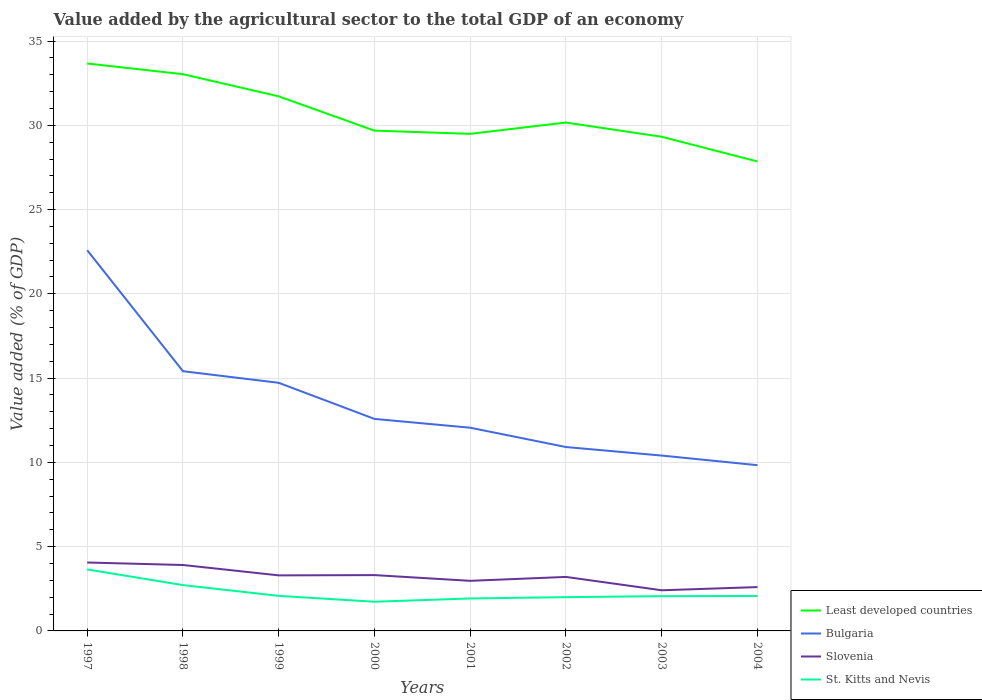How many different coloured lines are there?
Provide a short and direct response. 4. Across all years, what is the maximum value added by the agricultural sector to the total GDP in Bulgaria?
Your answer should be compact. 9.83. What is the total value added by the agricultural sector to the total GDP in Bulgaria in the graph?
Provide a succinct answer. 1.65. What is the difference between the highest and the second highest value added by the agricultural sector to the total GDP in Slovenia?
Offer a terse response. 1.65. What is the difference between the highest and the lowest value added by the agricultural sector to the total GDP in Slovenia?
Your response must be concise. 4. Does the graph contain grids?
Your answer should be very brief. Yes. How many legend labels are there?
Offer a terse response. 4. How are the legend labels stacked?
Your answer should be very brief. Vertical. What is the title of the graph?
Ensure brevity in your answer.  Value added by the agricultural sector to the total GDP of an economy. Does "Japan" appear as one of the legend labels in the graph?
Your answer should be very brief. No. What is the label or title of the X-axis?
Your response must be concise. Years. What is the label or title of the Y-axis?
Offer a terse response. Value added (% of GDP). What is the Value added (% of GDP) in Least developed countries in 1997?
Give a very brief answer. 33.67. What is the Value added (% of GDP) of Bulgaria in 1997?
Provide a succinct answer. 22.59. What is the Value added (% of GDP) of Slovenia in 1997?
Offer a very short reply. 4.06. What is the Value added (% of GDP) of St. Kitts and Nevis in 1997?
Provide a short and direct response. 3.65. What is the Value added (% of GDP) of Least developed countries in 1998?
Give a very brief answer. 33.04. What is the Value added (% of GDP) of Bulgaria in 1998?
Make the answer very short. 15.41. What is the Value added (% of GDP) in Slovenia in 1998?
Keep it short and to the point. 3.91. What is the Value added (% of GDP) in St. Kitts and Nevis in 1998?
Offer a terse response. 2.72. What is the Value added (% of GDP) in Least developed countries in 1999?
Give a very brief answer. 31.72. What is the Value added (% of GDP) in Bulgaria in 1999?
Offer a very short reply. 14.72. What is the Value added (% of GDP) of Slovenia in 1999?
Your answer should be very brief. 3.3. What is the Value added (% of GDP) in St. Kitts and Nevis in 1999?
Ensure brevity in your answer.  2.08. What is the Value added (% of GDP) of Least developed countries in 2000?
Your answer should be very brief. 29.69. What is the Value added (% of GDP) in Bulgaria in 2000?
Your response must be concise. 12.58. What is the Value added (% of GDP) of Slovenia in 2000?
Give a very brief answer. 3.31. What is the Value added (% of GDP) of St. Kitts and Nevis in 2000?
Your answer should be very brief. 1.73. What is the Value added (% of GDP) of Least developed countries in 2001?
Your answer should be compact. 29.49. What is the Value added (% of GDP) of Bulgaria in 2001?
Ensure brevity in your answer.  12.06. What is the Value added (% of GDP) in Slovenia in 2001?
Your answer should be compact. 2.97. What is the Value added (% of GDP) of St. Kitts and Nevis in 2001?
Offer a terse response. 1.93. What is the Value added (% of GDP) of Least developed countries in 2002?
Offer a terse response. 30.17. What is the Value added (% of GDP) of Bulgaria in 2002?
Your answer should be compact. 10.91. What is the Value added (% of GDP) in Slovenia in 2002?
Give a very brief answer. 3.2. What is the Value added (% of GDP) in St. Kitts and Nevis in 2002?
Offer a terse response. 2. What is the Value added (% of GDP) in Least developed countries in 2003?
Your answer should be very brief. 29.32. What is the Value added (% of GDP) in Bulgaria in 2003?
Make the answer very short. 10.4. What is the Value added (% of GDP) in Slovenia in 2003?
Your response must be concise. 2.41. What is the Value added (% of GDP) of St. Kitts and Nevis in 2003?
Ensure brevity in your answer.  2.06. What is the Value added (% of GDP) in Least developed countries in 2004?
Provide a succinct answer. 27.86. What is the Value added (% of GDP) of Bulgaria in 2004?
Provide a succinct answer. 9.83. What is the Value added (% of GDP) of Slovenia in 2004?
Your answer should be compact. 2.6. What is the Value added (% of GDP) in St. Kitts and Nevis in 2004?
Provide a succinct answer. 2.07. Across all years, what is the maximum Value added (% of GDP) of Least developed countries?
Provide a succinct answer. 33.67. Across all years, what is the maximum Value added (% of GDP) of Bulgaria?
Your answer should be very brief. 22.59. Across all years, what is the maximum Value added (% of GDP) of Slovenia?
Offer a terse response. 4.06. Across all years, what is the maximum Value added (% of GDP) in St. Kitts and Nevis?
Make the answer very short. 3.65. Across all years, what is the minimum Value added (% of GDP) in Least developed countries?
Make the answer very short. 27.86. Across all years, what is the minimum Value added (% of GDP) of Bulgaria?
Your answer should be compact. 9.83. Across all years, what is the minimum Value added (% of GDP) in Slovenia?
Provide a succinct answer. 2.41. Across all years, what is the minimum Value added (% of GDP) of St. Kitts and Nevis?
Make the answer very short. 1.73. What is the total Value added (% of GDP) in Least developed countries in the graph?
Offer a terse response. 244.95. What is the total Value added (% of GDP) of Bulgaria in the graph?
Make the answer very short. 108.51. What is the total Value added (% of GDP) of Slovenia in the graph?
Your answer should be compact. 25.77. What is the total Value added (% of GDP) in St. Kitts and Nevis in the graph?
Give a very brief answer. 18.25. What is the difference between the Value added (% of GDP) in Least developed countries in 1997 and that in 1998?
Keep it short and to the point. 0.63. What is the difference between the Value added (% of GDP) of Bulgaria in 1997 and that in 1998?
Give a very brief answer. 7.18. What is the difference between the Value added (% of GDP) in Slovenia in 1997 and that in 1998?
Your answer should be compact. 0.15. What is the difference between the Value added (% of GDP) of St. Kitts and Nevis in 1997 and that in 1998?
Provide a short and direct response. 0.93. What is the difference between the Value added (% of GDP) in Least developed countries in 1997 and that in 1999?
Provide a short and direct response. 1.95. What is the difference between the Value added (% of GDP) of Bulgaria in 1997 and that in 1999?
Give a very brief answer. 7.87. What is the difference between the Value added (% of GDP) of Slovenia in 1997 and that in 1999?
Provide a short and direct response. 0.76. What is the difference between the Value added (% of GDP) in St. Kitts and Nevis in 1997 and that in 1999?
Give a very brief answer. 1.57. What is the difference between the Value added (% of GDP) in Least developed countries in 1997 and that in 2000?
Give a very brief answer. 3.98. What is the difference between the Value added (% of GDP) in Bulgaria in 1997 and that in 2000?
Provide a succinct answer. 10.01. What is the difference between the Value added (% of GDP) in Slovenia in 1997 and that in 2000?
Your response must be concise. 0.75. What is the difference between the Value added (% of GDP) in St. Kitts and Nevis in 1997 and that in 2000?
Your answer should be compact. 1.92. What is the difference between the Value added (% of GDP) of Least developed countries in 1997 and that in 2001?
Offer a very short reply. 4.18. What is the difference between the Value added (% of GDP) of Bulgaria in 1997 and that in 2001?
Ensure brevity in your answer.  10.53. What is the difference between the Value added (% of GDP) of Slovenia in 1997 and that in 2001?
Provide a succinct answer. 1.09. What is the difference between the Value added (% of GDP) of St. Kitts and Nevis in 1997 and that in 2001?
Keep it short and to the point. 1.72. What is the difference between the Value added (% of GDP) of Least developed countries in 1997 and that in 2002?
Provide a succinct answer. 3.5. What is the difference between the Value added (% of GDP) of Bulgaria in 1997 and that in 2002?
Keep it short and to the point. 11.68. What is the difference between the Value added (% of GDP) in Slovenia in 1997 and that in 2002?
Make the answer very short. 0.86. What is the difference between the Value added (% of GDP) of St. Kitts and Nevis in 1997 and that in 2002?
Your response must be concise. 1.65. What is the difference between the Value added (% of GDP) in Least developed countries in 1997 and that in 2003?
Give a very brief answer. 4.35. What is the difference between the Value added (% of GDP) of Bulgaria in 1997 and that in 2003?
Make the answer very short. 12.18. What is the difference between the Value added (% of GDP) of Slovenia in 1997 and that in 2003?
Give a very brief answer. 1.65. What is the difference between the Value added (% of GDP) of St. Kitts and Nevis in 1997 and that in 2003?
Keep it short and to the point. 1.59. What is the difference between the Value added (% of GDP) in Least developed countries in 1997 and that in 2004?
Offer a terse response. 5.81. What is the difference between the Value added (% of GDP) in Bulgaria in 1997 and that in 2004?
Offer a very short reply. 12.75. What is the difference between the Value added (% of GDP) of Slovenia in 1997 and that in 2004?
Offer a very short reply. 1.46. What is the difference between the Value added (% of GDP) of St. Kitts and Nevis in 1997 and that in 2004?
Provide a succinct answer. 1.58. What is the difference between the Value added (% of GDP) in Least developed countries in 1998 and that in 1999?
Your answer should be compact. 1.31. What is the difference between the Value added (% of GDP) in Bulgaria in 1998 and that in 1999?
Provide a succinct answer. 0.69. What is the difference between the Value added (% of GDP) of Slovenia in 1998 and that in 1999?
Your response must be concise. 0.62. What is the difference between the Value added (% of GDP) of St. Kitts and Nevis in 1998 and that in 1999?
Offer a very short reply. 0.64. What is the difference between the Value added (% of GDP) in Least developed countries in 1998 and that in 2000?
Ensure brevity in your answer.  3.35. What is the difference between the Value added (% of GDP) in Bulgaria in 1998 and that in 2000?
Your answer should be very brief. 2.83. What is the difference between the Value added (% of GDP) of Slovenia in 1998 and that in 2000?
Provide a succinct answer. 0.6. What is the difference between the Value added (% of GDP) in St. Kitts and Nevis in 1998 and that in 2000?
Give a very brief answer. 0.99. What is the difference between the Value added (% of GDP) of Least developed countries in 1998 and that in 2001?
Provide a succinct answer. 3.54. What is the difference between the Value added (% of GDP) in Bulgaria in 1998 and that in 2001?
Give a very brief answer. 3.35. What is the difference between the Value added (% of GDP) of Slovenia in 1998 and that in 2001?
Keep it short and to the point. 0.94. What is the difference between the Value added (% of GDP) in St. Kitts and Nevis in 1998 and that in 2001?
Your response must be concise. 0.79. What is the difference between the Value added (% of GDP) in Least developed countries in 1998 and that in 2002?
Provide a succinct answer. 2.87. What is the difference between the Value added (% of GDP) of Bulgaria in 1998 and that in 2002?
Your answer should be compact. 4.5. What is the difference between the Value added (% of GDP) in Slovenia in 1998 and that in 2002?
Provide a short and direct response. 0.71. What is the difference between the Value added (% of GDP) in St. Kitts and Nevis in 1998 and that in 2002?
Your answer should be very brief. 0.72. What is the difference between the Value added (% of GDP) of Least developed countries in 1998 and that in 2003?
Provide a succinct answer. 3.71. What is the difference between the Value added (% of GDP) in Bulgaria in 1998 and that in 2003?
Give a very brief answer. 5.01. What is the difference between the Value added (% of GDP) in Slovenia in 1998 and that in 2003?
Your response must be concise. 1.5. What is the difference between the Value added (% of GDP) in St. Kitts and Nevis in 1998 and that in 2003?
Ensure brevity in your answer.  0.66. What is the difference between the Value added (% of GDP) of Least developed countries in 1998 and that in 2004?
Your answer should be compact. 5.18. What is the difference between the Value added (% of GDP) in Bulgaria in 1998 and that in 2004?
Your answer should be compact. 5.58. What is the difference between the Value added (% of GDP) in Slovenia in 1998 and that in 2004?
Offer a terse response. 1.31. What is the difference between the Value added (% of GDP) in St. Kitts and Nevis in 1998 and that in 2004?
Keep it short and to the point. 0.65. What is the difference between the Value added (% of GDP) in Least developed countries in 1999 and that in 2000?
Keep it short and to the point. 2.03. What is the difference between the Value added (% of GDP) of Bulgaria in 1999 and that in 2000?
Keep it short and to the point. 2.14. What is the difference between the Value added (% of GDP) in Slovenia in 1999 and that in 2000?
Your response must be concise. -0.02. What is the difference between the Value added (% of GDP) in St. Kitts and Nevis in 1999 and that in 2000?
Ensure brevity in your answer.  0.35. What is the difference between the Value added (% of GDP) in Least developed countries in 1999 and that in 2001?
Provide a succinct answer. 2.23. What is the difference between the Value added (% of GDP) in Bulgaria in 1999 and that in 2001?
Provide a succinct answer. 2.66. What is the difference between the Value added (% of GDP) in Slovenia in 1999 and that in 2001?
Your answer should be very brief. 0.32. What is the difference between the Value added (% of GDP) in St. Kitts and Nevis in 1999 and that in 2001?
Ensure brevity in your answer.  0.16. What is the difference between the Value added (% of GDP) in Least developed countries in 1999 and that in 2002?
Your answer should be compact. 1.55. What is the difference between the Value added (% of GDP) in Bulgaria in 1999 and that in 2002?
Keep it short and to the point. 3.81. What is the difference between the Value added (% of GDP) in Slovenia in 1999 and that in 2002?
Offer a terse response. 0.09. What is the difference between the Value added (% of GDP) of St. Kitts and Nevis in 1999 and that in 2002?
Offer a very short reply. 0.08. What is the difference between the Value added (% of GDP) of Least developed countries in 1999 and that in 2003?
Your response must be concise. 2.4. What is the difference between the Value added (% of GDP) in Bulgaria in 1999 and that in 2003?
Your answer should be very brief. 4.32. What is the difference between the Value added (% of GDP) of Slovenia in 1999 and that in 2003?
Ensure brevity in your answer.  0.88. What is the difference between the Value added (% of GDP) of St. Kitts and Nevis in 1999 and that in 2003?
Your answer should be compact. 0.02. What is the difference between the Value added (% of GDP) of Least developed countries in 1999 and that in 2004?
Offer a terse response. 3.86. What is the difference between the Value added (% of GDP) in Bulgaria in 1999 and that in 2004?
Ensure brevity in your answer.  4.89. What is the difference between the Value added (% of GDP) in Slovenia in 1999 and that in 2004?
Offer a terse response. 0.69. What is the difference between the Value added (% of GDP) of St. Kitts and Nevis in 1999 and that in 2004?
Provide a short and direct response. 0.01. What is the difference between the Value added (% of GDP) in Least developed countries in 2000 and that in 2001?
Provide a short and direct response. 0.19. What is the difference between the Value added (% of GDP) in Bulgaria in 2000 and that in 2001?
Ensure brevity in your answer.  0.52. What is the difference between the Value added (% of GDP) in Slovenia in 2000 and that in 2001?
Provide a succinct answer. 0.34. What is the difference between the Value added (% of GDP) of St. Kitts and Nevis in 2000 and that in 2001?
Your answer should be very brief. -0.19. What is the difference between the Value added (% of GDP) of Least developed countries in 2000 and that in 2002?
Ensure brevity in your answer.  -0.48. What is the difference between the Value added (% of GDP) of Bulgaria in 2000 and that in 2002?
Ensure brevity in your answer.  1.67. What is the difference between the Value added (% of GDP) of Slovenia in 2000 and that in 2002?
Your answer should be very brief. 0.11. What is the difference between the Value added (% of GDP) in St. Kitts and Nevis in 2000 and that in 2002?
Provide a succinct answer. -0.27. What is the difference between the Value added (% of GDP) of Least developed countries in 2000 and that in 2003?
Offer a very short reply. 0.37. What is the difference between the Value added (% of GDP) in Bulgaria in 2000 and that in 2003?
Keep it short and to the point. 2.17. What is the difference between the Value added (% of GDP) in Slovenia in 2000 and that in 2003?
Your response must be concise. 0.9. What is the difference between the Value added (% of GDP) in St. Kitts and Nevis in 2000 and that in 2003?
Make the answer very short. -0.33. What is the difference between the Value added (% of GDP) of Least developed countries in 2000 and that in 2004?
Give a very brief answer. 1.83. What is the difference between the Value added (% of GDP) of Bulgaria in 2000 and that in 2004?
Keep it short and to the point. 2.75. What is the difference between the Value added (% of GDP) of Slovenia in 2000 and that in 2004?
Give a very brief answer. 0.71. What is the difference between the Value added (% of GDP) of St. Kitts and Nevis in 2000 and that in 2004?
Your answer should be compact. -0.34. What is the difference between the Value added (% of GDP) of Least developed countries in 2001 and that in 2002?
Your response must be concise. -0.67. What is the difference between the Value added (% of GDP) of Bulgaria in 2001 and that in 2002?
Your response must be concise. 1.15. What is the difference between the Value added (% of GDP) of Slovenia in 2001 and that in 2002?
Ensure brevity in your answer.  -0.23. What is the difference between the Value added (% of GDP) in St. Kitts and Nevis in 2001 and that in 2002?
Provide a succinct answer. -0.08. What is the difference between the Value added (% of GDP) in Least developed countries in 2001 and that in 2003?
Keep it short and to the point. 0.17. What is the difference between the Value added (% of GDP) in Bulgaria in 2001 and that in 2003?
Offer a very short reply. 1.65. What is the difference between the Value added (% of GDP) in Slovenia in 2001 and that in 2003?
Your response must be concise. 0.56. What is the difference between the Value added (% of GDP) in St. Kitts and Nevis in 2001 and that in 2003?
Make the answer very short. -0.14. What is the difference between the Value added (% of GDP) in Least developed countries in 2001 and that in 2004?
Give a very brief answer. 1.64. What is the difference between the Value added (% of GDP) in Bulgaria in 2001 and that in 2004?
Offer a very short reply. 2.22. What is the difference between the Value added (% of GDP) in Slovenia in 2001 and that in 2004?
Ensure brevity in your answer.  0.37. What is the difference between the Value added (% of GDP) of St. Kitts and Nevis in 2001 and that in 2004?
Ensure brevity in your answer.  -0.15. What is the difference between the Value added (% of GDP) in Least developed countries in 2002 and that in 2003?
Provide a succinct answer. 0.85. What is the difference between the Value added (% of GDP) of Bulgaria in 2002 and that in 2003?
Keep it short and to the point. 0.51. What is the difference between the Value added (% of GDP) of Slovenia in 2002 and that in 2003?
Ensure brevity in your answer.  0.79. What is the difference between the Value added (% of GDP) of St. Kitts and Nevis in 2002 and that in 2003?
Offer a terse response. -0.06. What is the difference between the Value added (% of GDP) of Least developed countries in 2002 and that in 2004?
Provide a short and direct response. 2.31. What is the difference between the Value added (% of GDP) in Bulgaria in 2002 and that in 2004?
Give a very brief answer. 1.08. What is the difference between the Value added (% of GDP) in Slovenia in 2002 and that in 2004?
Provide a succinct answer. 0.6. What is the difference between the Value added (% of GDP) in St. Kitts and Nevis in 2002 and that in 2004?
Your answer should be very brief. -0.07. What is the difference between the Value added (% of GDP) of Least developed countries in 2003 and that in 2004?
Keep it short and to the point. 1.46. What is the difference between the Value added (% of GDP) in Bulgaria in 2003 and that in 2004?
Provide a short and direct response. 0.57. What is the difference between the Value added (% of GDP) in Slovenia in 2003 and that in 2004?
Your answer should be compact. -0.19. What is the difference between the Value added (% of GDP) of St. Kitts and Nevis in 2003 and that in 2004?
Provide a succinct answer. -0.01. What is the difference between the Value added (% of GDP) of Least developed countries in 1997 and the Value added (% of GDP) of Bulgaria in 1998?
Make the answer very short. 18.26. What is the difference between the Value added (% of GDP) in Least developed countries in 1997 and the Value added (% of GDP) in Slovenia in 1998?
Offer a very short reply. 29.76. What is the difference between the Value added (% of GDP) of Least developed countries in 1997 and the Value added (% of GDP) of St. Kitts and Nevis in 1998?
Offer a terse response. 30.95. What is the difference between the Value added (% of GDP) of Bulgaria in 1997 and the Value added (% of GDP) of Slovenia in 1998?
Make the answer very short. 18.68. What is the difference between the Value added (% of GDP) in Bulgaria in 1997 and the Value added (% of GDP) in St. Kitts and Nevis in 1998?
Make the answer very short. 19.87. What is the difference between the Value added (% of GDP) in Slovenia in 1997 and the Value added (% of GDP) in St. Kitts and Nevis in 1998?
Your answer should be very brief. 1.34. What is the difference between the Value added (% of GDP) in Least developed countries in 1997 and the Value added (% of GDP) in Bulgaria in 1999?
Provide a succinct answer. 18.95. What is the difference between the Value added (% of GDP) in Least developed countries in 1997 and the Value added (% of GDP) in Slovenia in 1999?
Offer a terse response. 30.37. What is the difference between the Value added (% of GDP) of Least developed countries in 1997 and the Value added (% of GDP) of St. Kitts and Nevis in 1999?
Make the answer very short. 31.59. What is the difference between the Value added (% of GDP) of Bulgaria in 1997 and the Value added (% of GDP) of Slovenia in 1999?
Your response must be concise. 19.29. What is the difference between the Value added (% of GDP) in Bulgaria in 1997 and the Value added (% of GDP) in St. Kitts and Nevis in 1999?
Provide a succinct answer. 20.51. What is the difference between the Value added (% of GDP) in Slovenia in 1997 and the Value added (% of GDP) in St. Kitts and Nevis in 1999?
Provide a succinct answer. 1.98. What is the difference between the Value added (% of GDP) in Least developed countries in 1997 and the Value added (% of GDP) in Bulgaria in 2000?
Provide a succinct answer. 21.09. What is the difference between the Value added (% of GDP) in Least developed countries in 1997 and the Value added (% of GDP) in Slovenia in 2000?
Keep it short and to the point. 30.36. What is the difference between the Value added (% of GDP) in Least developed countries in 1997 and the Value added (% of GDP) in St. Kitts and Nevis in 2000?
Offer a terse response. 31.94. What is the difference between the Value added (% of GDP) of Bulgaria in 1997 and the Value added (% of GDP) of Slovenia in 2000?
Give a very brief answer. 19.28. What is the difference between the Value added (% of GDP) in Bulgaria in 1997 and the Value added (% of GDP) in St. Kitts and Nevis in 2000?
Provide a short and direct response. 20.86. What is the difference between the Value added (% of GDP) in Slovenia in 1997 and the Value added (% of GDP) in St. Kitts and Nevis in 2000?
Your answer should be very brief. 2.33. What is the difference between the Value added (% of GDP) in Least developed countries in 1997 and the Value added (% of GDP) in Bulgaria in 2001?
Your answer should be compact. 21.61. What is the difference between the Value added (% of GDP) in Least developed countries in 1997 and the Value added (% of GDP) in Slovenia in 2001?
Give a very brief answer. 30.7. What is the difference between the Value added (% of GDP) of Least developed countries in 1997 and the Value added (% of GDP) of St. Kitts and Nevis in 2001?
Your response must be concise. 31.74. What is the difference between the Value added (% of GDP) of Bulgaria in 1997 and the Value added (% of GDP) of Slovenia in 2001?
Ensure brevity in your answer.  19.62. What is the difference between the Value added (% of GDP) of Bulgaria in 1997 and the Value added (% of GDP) of St. Kitts and Nevis in 2001?
Give a very brief answer. 20.66. What is the difference between the Value added (% of GDP) in Slovenia in 1997 and the Value added (% of GDP) in St. Kitts and Nevis in 2001?
Ensure brevity in your answer.  2.13. What is the difference between the Value added (% of GDP) in Least developed countries in 1997 and the Value added (% of GDP) in Bulgaria in 2002?
Make the answer very short. 22.76. What is the difference between the Value added (% of GDP) in Least developed countries in 1997 and the Value added (% of GDP) in Slovenia in 2002?
Keep it short and to the point. 30.46. What is the difference between the Value added (% of GDP) of Least developed countries in 1997 and the Value added (% of GDP) of St. Kitts and Nevis in 2002?
Your response must be concise. 31.67. What is the difference between the Value added (% of GDP) of Bulgaria in 1997 and the Value added (% of GDP) of Slovenia in 2002?
Offer a very short reply. 19.39. What is the difference between the Value added (% of GDP) of Bulgaria in 1997 and the Value added (% of GDP) of St. Kitts and Nevis in 2002?
Make the answer very short. 20.59. What is the difference between the Value added (% of GDP) in Slovenia in 1997 and the Value added (% of GDP) in St. Kitts and Nevis in 2002?
Keep it short and to the point. 2.06. What is the difference between the Value added (% of GDP) of Least developed countries in 1997 and the Value added (% of GDP) of Bulgaria in 2003?
Your answer should be very brief. 23.26. What is the difference between the Value added (% of GDP) in Least developed countries in 1997 and the Value added (% of GDP) in Slovenia in 2003?
Make the answer very short. 31.26. What is the difference between the Value added (% of GDP) of Least developed countries in 1997 and the Value added (% of GDP) of St. Kitts and Nevis in 2003?
Offer a very short reply. 31.61. What is the difference between the Value added (% of GDP) in Bulgaria in 1997 and the Value added (% of GDP) in Slovenia in 2003?
Offer a terse response. 20.18. What is the difference between the Value added (% of GDP) in Bulgaria in 1997 and the Value added (% of GDP) in St. Kitts and Nevis in 2003?
Keep it short and to the point. 20.53. What is the difference between the Value added (% of GDP) in Slovenia in 1997 and the Value added (% of GDP) in St. Kitts and Nevis in 2003?
Your response must be concise. 2. What is the difference between the Value added (% of GDP) in Least developed countries in 1997 and the Value added (% of GDP) in Bulgaria in 2004?
Keep it short and to the point. 23.83. What is the difference between the Value added (% of GDP) of Least developed countries in 1997 and the Value added (% of GDP) of Slovenia in 2004?
Make the answer very short. 31.07. What is the difference between the Value added (% of GDP) in Least developed countries in 1997 and the Value added (% of GDP) in St. Kitts and Nevis in 2004?
Provide a short and direct response. 31.6. What is the difference between the Value added (% of GDP) in Bulgaria in 1997 and the Value added (% of GDP) in Slovenia in 2004?
Your response must be concise. 19.99. What is the difference between the Value added (% of GDP) in Bulgaria in 1997 and the Value added (% of GDP) in St. Kitts and Nevis in 2004?
Offer a very short reply. 20.52. What is the difference between the Value added (% of GDP) of Slovenia in 1997 and the Value added (% of GDP) of St. Kitts and Nevis in 2004?
Make the answer very short. 1.99. What is the difference between the Value added (% of GDP) of Least developed countries in 1998 and the Value added (% of GDP) of Bulgaria in 1999?
Give a very brief answer. 18.31. What is the difference between the Value added (% of GDP) of Least developed countries in 1998 and the Value added (% of GDP) of Slovenia in 1999?
Your answer should be very brief. 29.74. What is the difference between the Value added (% of GDP) of Least developed countries in 1998 and the Value added (% of GDP) of St. Kitts and Nevis in 1999?
Provide a short and direct response. 30.95. What is the difference between the Value added (% of GDP) of Bulgaria in 1998 and the Value added (% of GDP) of Slovenia in 1999?
Keep it short and to the point. 12.12. What is the difference between the Value added (% of GDP) of Bulgaria in 1998 and the Value added (% of GDP) of St. Kitts and Nevis in 1999?
Keep it short and to the point. 13.33. What is the difference between the Value added (% of GDP) in Slovenia in 1998 and the Value added (% of GDP) in St. Kitts and Nevis in 1999?
Your answer should be compact. 1.83. What is the difference between the Value added (% of GDP) of Least developed countries in 1998 and the Value added (% of GDP) of Bulgaria in 2000?
Your response must be concise. 20.46. What is the difference between the Value added (% of GDP) of Least developed countries in 1998 and the Value added (% of GDP) of Slovenia in 2000?
Offer a terse response. 29.72. What is the difference between the Value added (% of GDP) in Least developed countries in 1998 and the Value added (% of GDP) in St. Kitts and Nevis in 2000?
Offer a very short reply. 31.3. What is the difference between the Value added (% of GDP) in Bulgaria in 1998 and the Value added (% of GDP) in Slovenia in 2000?
Your answer should be compact. 12.1. What is the difference between the Value added (% of GDP) in Bulgaria in 1998 and the Value added (% of GDP) in St. Kitts and Nevis in 2000?
Keep it short and to the point. 13.68. What is the difference between the Value added (% of GDP) of Slovenia in 1998 and the Value added (% of GDP) of St. Kitts and Nevis in 2000?
Your answer should be very brief. 2.18. What is the difference between the Value added (% of GDP) of Least developed countries in 1998 and the Value added (% of GDP) of Bulgaria in 2001?
Provide a succinct answer. 20.98. What is the difference between the Value added (% of GDP) in Least developed countries in 1998 and the Value added (% of GDP) in Slovenia in 2001?
Offer a terse response. 30.06. What is the difference between the Value added (% of GDP) of Least developed countries in 1998 and the Value added (% of GDP) of St. Kitts and Nevis in 2001?
Make the answer very short. 31.11. What is the difference between the Value added (% of GDP) of Bulgaria in 1998 and the Value added (% of GDP) of Slovenia in 2001?
Provide a succinct answer. 12.44. What is the difference between the Value added (% of GDP) of Bulgaria in 1998 and the Value added (% of GDP) of St. Kitts and Nevis in 2001?
Your answer should be compact. 13.49. What is the difference between the Value added (% of GDP) of Slovenia in 1998 and the Value added (% of GDP) of St. Kitts and Nevis in 2001?
Provide a succinct answer. 1.99. What is the difference between the Value added (% of GDP) of Least developed countries in 1998 and the Value added (% of GDP) of Bulgaria in 2002?
Give a very brief answer. 22.12. What is the difference between the Value added (% of GDP) in Least developed countries in 1998 and the Value added (% of GDP) in Slovenia in 2002?
Provide a succinct answer. 29.83. What is the difference between the Value added (% of GDP) of Least developed countries in 1998 and the Value added (% of GDP) of St. Kitts and Nevis in 2002?
Give a very brief answer. 31.03. What is the difference between the Value added (% of GDP) of Bulgaria in 1998 and the Value added (% of GDP) of Slovenia in 2002?
Your answer should be very brief. 12.21. What is the difference between the Value added (% of GDP) of Bulgaria in 1998 and the Value added (% of GDP) of St. Kitts and Nevis in 2002?
Provide a short and direct response. 13.41. What is the difference between the Value added (% of GDP) of Slovenia in 1998 and the Value added (% of GDP) of St. Kitts and Nevis in 2002?
Your response must be concise. 1.91. What is the difference between the Value added (% of GDP) of Least developed countries in 1998 and the Value added (% of GDP) of Bulgaria in 2003?
Your answer should be compact. 22.63. What is the difference between the Value added (% of GDP) of Least developed countries in 1998 and the Value added (% of GDP) of Slovenia in 2003?
Make the answer very short. 30.62. What is the difference between the Value added (% of GDP) of Least developed countries in 1998 and the Value added (% of GDP) of St. Kitts and Nevis in 2003?
Give a very brief answer. 30.97. What is the difference between the Value added (% of GDP) in Bulgaria in 1998 and the Value added (% of GDP) in Slovenia in 2003?
Your answer should be compact. 13. What is the difference between the Value added (% of GDP) of Bulgaria in 1998 and the Value added (% of GDP) of St. Kitts and Nevis in 2003?
Make the answer very short. 13.35. What is the difference between the Value added (% of GDP) of Slovenia in 1998 and the Value added (% of GDP) of St. Kitts and Nevis in 2003?
Give a very brief answer. 1.85. What is the difference between the Value added (% of GDP) of Least developed countries in 1998 and the Value added (% of GDP) of Bulgaria in 2004?
Provide a short and direct response. 23.2. What is the difference between the Value added (% of GDP) of Least developed countries in 1998 and the Value added (% of GDP) of Slovenia in 2004?
Offer a very short reply. 30.43. What is the difference between the Value added (% of GDP) of Least developed countries in 1998 and the Value added (% of GDP) of St. Kitts and Nevis in 2004?
Your answer should be compact. 30.96. What is the difference between the Value added (% of GDP) in Bulgaria in 1998 and the Value added (% of GDP) in Slovenia in 2004?
Keep it short and to the point. 12.81. What is the difference between the Value added (% of GDP) in Bulgaria in 1998 and the Value added (% of GDP) in St. Kitts and Nevis in 2004?
Give a very brief answer. 13.34. What is the difference between the Value added (% of GDP) of Slovenia in 1998 and the Value added (% of GDP) of St. Kitts and Nevis in 2004?
Make the answer very short. 1.84. What is the difference between the Value added (% of GDP) in Least developed countries in 1999 and the Value added (% of GDP) in Bulgaria in 2000?
Provide a succinct answer. 19.14. What is the difference between the Value added (% of GDP) of Least developed countries in 1999 and the Value added (% of GDP) of Slovenia in 2000?
Provide a succinct answer. 28.41. What is the difference between the Value added (% of GDP) in Least developed countries in 1999 and the Value added (% of GDP) in St. Kitts and Nevis in 2000?
Ensure brevity in your answer.  29.99. What is the difference between the Value added (% of GDP) in Bulgaria in 1999 and the Value added (% of GDP) in Slovenia in 2000?
Your answer should be compact. 11.41. What is the difference between the Value added (% of GDP) of Bulgaria in 1999 and the Value added (% of GDP) of St. Kitts and Nevis in 2000?
Provide a succinct answer. 12.99. What is the difference between the Value added (% of GDP) of Slovenia in 1999 and the Value added (% of GDP) of St. Kitts and Nevis in 2000?
Your answer should be very brief. 1.56. What is the difference between the Value added (% of GDP) in Least developed countries in 1999 and the Value added (% of GDP) in Bulgaria in 2001?
Your response must be concise. 19.66. What is the difference between the Value added (% of GDP) in Least developed countries in 1999 and the Value added (% of GDP) in Slovenia in 2001?
Offer a terse response. 28.75. What is the difference between the Value added (% of GDP) of Least developed countries in 1999 and the Value added (% of GDP) of St. Kitts and Nevis in 2001?
Give a very brief answer. 29.8. What is the difference between the Value added (% of GDP) in Bulgaria in 1999 and the Value added (% of GDP) in Slovenia in 2001?
Offer a terse response. 11.75. What is the difference between the Value added (% of GDP) of Bulgaria in 1999 and the Value added (% of GDP) of St. Kitts and Nevis in 2001?
Offer a very short reply. 12.8. What is the difference between the Value added (% of GDP) of Slovenia in 1999 and the Value added (% of GDP) of St. Kitts and Nevis in 2001?
Make the answer very short. 1.37. What is the difference between the Value added (% of GDP) in Least developed countries in 1999 and the Value added (% of GDP) in Bulgaria in 2002?
Keep it short and to the point. 20.81. What is the difference between the Value added (% of GDP) in Least developed countries in 1999 and the Value added (% of GDP) in Slovenia in 2002?
Offer a terse response. 28.52. What is the difference between the Value added (% of GDP) of Least developed countries in 1999 and the Value added (% of GDP) of St. Kitts and Nevis in 2002?
Ensure brevity in your answer.  29.72. What is the difference between the Value added (% of GDP) of Bulgaria in 1999 and the Value added (% of GDP) of Slovenia in 2002?
Give a very brief answer. 11.52. What is the difference between the Value added (% of GDP) of Bulgaria in 1999 and the Value added (% of GDP) of St. Kitts and Nevis in 2002?
Your answer should be compact. 12.72. What is the difference between the Value added (% of GDP) of Slovenia in 1999 and the Value added (% of GDP) of St. Kitts and Nevis in 2002?
Make the answer very short. 1.29. What is the difference between the Value added (% of GDP) in Least developed countries in 1999 and the Value added (% of GDP) in Bulgaria in 2003?
Offer a terse response. 21.32. What is the difference between the Value added (% of GDP) in Least developed countries in 1999 and the Value added (% of GDP) in Slovenia in 2003?
Your answer should be compact. 29.31. What is the difference between the Value added (% of GDP) of Least developed countries in 1999 and the Value added (% of GDP) of St. Kitts and Nevis in 2003?
Offer a very short reply. 29.66. What is the difference between the Value added (% of GDP) in Bulgaria in 1999 and the Value added (% of GDP) in Slovenia in 2003?
Your answer should be very brief. 12.31. What is the difference between the Value added (% of GDP) in Bulgaria in 1999 and the Value added (% of GDP) in St. Kitts and Nevis in 2003?
Your response must be concise. 12.66. What is the difference between the Value added (% of GDP) of Slovenia in 1999 and the Value added (% of GDP) of St. Kitts and Nevis in 2003?
Give a very brief answer. 1.23. What is the difference between the Value added (% of GDP) in Least developed countries in 1999 and the Value added (% of GDP) in Bulgaria in 2004?
Offer a terse response. 21.89. What is the difference between the Value added (% of GDP) of Least developed countries in 1999 and the Value added (% of GDP) of Slovenia in 2004?
Your answer should be compact. 29.12. What is the difference between the Value added (% of GDP) of Least developed countries in 1999 and the Value added (% of GDP) of St. Kitts and Nevis in 2004?
Provide a succinct answer. 29.65. What is the difference between the Value added (% of GDP) of Bulgaria in 1999 and the Value added (% of GDP) of Slovenia in 2004?
Your response must be concise. 12.12. What is the difference between the Value added (% of GDP) of Bulgaria in 1999 and the Value added (% of GDP) of St. Kitts and Nevis in 2004?
Your response must be concise. 12.65. What is the difference between the Value added (% of GDP) in Slovenia in 1999 and the Value added (% of GDP) in St. Kitts and Nevis in 2004?
Your answer should be compact. 1.22. What is the difference between the Value added (% of GDP) of Least developed countries in 2000 and the Value added (% of GDP) of Bulgaria in 2001?
Keep it short and to the point. 17.63. What is the difference between the Value added (% of GDP) of Least developed countries in 2000 and the Value added (% of GDP) of Slovenia in 2001?
Your answer should be compact. 26.71. What is the difference between the Value added (% of GDP) of Least developed countries in 2000 and the Value added (% of GDP) of St. Kitts and Nevis in 2001?
Keep it short and to the point. 27.76. What is the difference between the Value added (% of GDP) of Bulgaria in 2000 and the Value added (% of GDP) of Slovenia in 2001?
Your answer should be compact. 9.61. What is the difference between the Value added (% of GDP) in Bulgaria in 2000 and the Value added (% of GDP) in St. Kitts and Nevis in 2001?
Ensure brevity in your answer.  10.65. What is the difference between the Value added (% of GDP) in Slovenia in 2000 and the Value added (% of GDP) in St. Kitts and Nevis in 2001?
Offer a terse response. 1.39. What is the difference between the Value added (% of GDP) in Least developed countries in 2000 and the Value added (% of GDP) in Bulgaria in 2002?
Your response must be concise. 18.78. What is the difference between the Value added (% of GDP) in Least developed countries in 2000 and the Value added (% of GDP) in Slovenia in 2002?
Keep it short and to the point. 26.48. What is the difference between the Value added (% of GDP) of Least developed countries in 2000 and the Value added (% of GDP) of St. Kitts and Nevis in 2002?
Ensure brevity in your answer.  27.68. What is the difference between the Value added (% of GDP) in Bulgaria in 2000 and the Value added (% of GDP) in Slovenia in 2002?
Make the answer very short. 9.38. What is the difference between the Value added (% of GDP) of Bulgaria in 2000 and the Value added (% of GDP) of St. Kitts and Nevis in 2002?
Ensure brevity in your answer.  10.58. What is the difference between the Value added (% of GDP) of Slovenia in 2000 and the Value added (% of GDP) of St. Kitts and Nevis in 2002?
Your response must be concise. 1.31. What is the difference between the Value added (% of GDP) in Least developed countries in 2000 and the Value added (% of GDP) in Bulgaria in 2003?
Your answer should be compact. 19.28. What is the difference between the Value added (% of GDP) of Least developed countries in 2000 and the Value added (% of GDP) of Slovenia in 2003?
Offer a very short reply. 27.27. What is the difference between the Value added (% of GDP) in Least developed countries in 2000 and the Value added (% of GDP) in St. Kitts and Nevis in 2003?
Ensure brevity in your answer.  27.62. What is the difference between the Value added (% of GDP) of Bulgaria in 2000 and the Value added (% of GDP) of Slovenia in 2003?
Give a very brief answer. 10.17. What is the difference between the Value added (% of GDP) of Bulgaria in 2000 and the Value added (% of GDP) of St. Kitts and Nevis in 2003?
Your answer should be very brief. 10.52. What is the difference between the Value added (% of GDP) in Slovenia in 2000 and the Value added (% of GDP) in St. Kitts and Nevis in 2003?
Provide a short and direct response. 1.25. What is the difference between the Value added (% of GDP) of Least developed countries in 2000 and the Value added (% of GDP) of Bulgaria in 2004?
Provide a succinct answer. 19.85. What is the difference between the Value added (% of GDP) in Least developed countries in 2000 and the Value added (% of GDP) in Slovenia in 2004?
Your answer should be compact. 27.09. What is the difference between the Value added (% of GDP) in Least developed countries in 2000 and the Value added (% of GDP) in St. Kitts and Nevis in 2004?
Offer a terse response. 27.61. What is the difference between the Value added (% of GDP) of Bulgaria in 2000 and the Value added (% of GDP) of Slovenia in 2004?
Your response must be concise. 9.98. What is the difference between the Value added (% of GDP) in Bulgaria in 2000 and the Value added (% of GDP) in St. Kitts and Nevis in 2004?
Provide a succinct answer. 10.51. What is the difference between the Value added (% of GDP) in Slovenia in 2000 and the Value added (% of GDP) in St. Kitts and Nevis in 2004?
Ensure brevity in your answer.  1.24. What is the difference between the Value added (% of GDP) in Least developed countries in 2001 and the Value added (% of GDP) in Bulgaria in 2002?
Give a very brief answer. 18.58. What is the difference between the Value added (% of GDP) in Least developed countries in 2001 and the Value added (% of GDP) in Slovenia in 2002?
Offer a terse response. 26.29. What is the difference between the Value added (% of GDP) of Least developed countries in 2001 and the Value added (% of GDP) of St. Kitts and Nevis in 2002?
Your answer should be very brief. 27.49. What is the difference between the Value added (% of GDP) of Bulgaria in 2001 and the Value added (% of GDP) of Slovenia in 2002?
Ensure brevity in your answer.  8.85. What is the difference between the Value added (% of GDP) of Bulgaria in 2001 and the Value added (% of GDP) of St. Kitts and Nevis in 2002?
Give a very brief answer. 10.05. What is the difference between the Value added (% of GDP) in Slovenia in 2001 and the Value added (% of GDP) in St. Kitts and Nevis in 2002?
Keep it short and to the point. 0.97. What is the difference between the Value added (% of GDP) of Least developed countries in 2001 and the Value added (% of GDP) of Bulgaria in 2003?
Offer a terse response. 19.09. What is the difference between the Value added (% of GDP) in Least developed countries in 2001 and the Value added (% of GDP) in Slovenia in 2003?
Give a very brief answer. 27.08. What is the difference between the Value added (% of GDP) of Least developed countries in 2001 and the Value added (% of GDP) of St. Kitts and Nevis in 2003?
Your response must be concise. 27.43. What is the difference between the Value added (% of GDP) in Bulgaria in 2001 and the Value added (% of GDP) in Slovenia in 2003?
Your answer should be compact. 9.65. What is the difference between the Value added (% of GDP) of Bulgaria in 2001 and the Value added (% of GDP) of St. Kitts and Nevis in 2003?
Your answer should be compact. 9.99. What is the difference between the Value added (% of GDP) in Slovenia in 2001 and the Value added (% of GDP) in St. Kitts and Nevis in 2003?
Ensure brevity in your answer.  0.91. What is the difference between the Value added (% of GDP) of Least developed countries in 2001 and the Value added (% of GDP) of Bulgaria in 2004?
Make the answer very short. 19.66. What is the difference between the Value added (% of GDP) in Least developed countries in 2001 and the Value added (% of GDP) in Slovenia in 2004?
Provide a short and direct response. 26.89. What is the difference between the Value added (% of GDP) of Least developed countries in 2001 and the Value added (% of GDP) of St. Kitts and Nevis in 2004?
Give a very brief answer. 27.42. What is the difference between the Value added (% of GDP) in Bulgaria in 2001 and the Value added (% of GDP) in Slovenia in 2004?
Offer a very short reply. 9.46. What is the difference between the Value added (% of GDP) of Bulgaria in 2001 and the Value added (% of GDP) of St. Kitts and Nevis in 2004?
Make the answer very short. 9.98. What is the difference between the Value added (% of GDP) in Slovenia in 2001 and the Value added (% of GDP) in St. Kitts and Nevis in 2004?
Offer a very short reply. 0.9. What is the difference between the Value added (% of GDP) of Least developed countries in 2002 and the Value added (% of GDP) of Bulgaria in 2003?
Your response must be concise. 19.76. What is the difference between the Value added (% of GDP) of Least developed countries in 2002 and the Value added (% of GDP) of Slovenia in 2003?
Your answer should be compact. 27.75. What is the difference between the Value added (% of GDP) of Least developed countries in 2002 and the Value added (% of GDP) of St. Kitts and Nevis in 2003?
Ensure brevity in your answer.  28.1. What is the difference between the Value added (% of GDP) in Bulgaria in 2002 and the Value added (% of GDP) in Slovenia in 2003?
Provide a succinct answer. 8.5. What is the difference between the Value added (% of GDP) in Bulgaria in 2002 and the Value added (% of GDP) in St. Kitts and Nevis in 2003?
Your response must be concise. 8.85. What is the difference between the Value added (% of GDP) of Slovenia in 2002 and the Value added (% of GDP) of St. Kitts and Nevis in 2003?
Keep it short and to the point. 1.14. What is the difference between the Value added (% of GDP) in Least developed countries in 2002 and the Value added (% of GDP) in Bulgaria in 2004?
Make the answer very short. 20.33. What is the difference between the Value added (% of GDP) of Least developed countries in 2002 and the Value added (% of GDP) of Slovenia in 2004?
Provide a short and direct response. 27.56. What is the difference between the Value added (% of GDP) in Least developed countries in 2002 and the Value added (% of GDP) in St. Kitts and Nevis in 2004?
Ensure brevity in your answer.  28.09. What is the difference between the Value added (% of GDP) of Bulgaria in 2002 and the Value added (% of GDP) of Slovenia in 2004?
Keep it short and to the point. 8.31. What is the difference between the Value added (% of GDP) in Bulgaria in 2002 and the Value added (% of GDP) in St. Kitts and Nevis in 2004?
Keep it short and to the point. 8.84. What is the difference between the Value added (% of GDP) in Slovenia in 2002 and the Value added (% of GDP) in St. Kitts and Nevis in 2004?
Your answer should be very brief. 1.13. What is the difference between the Value added (% of GDP) in Least developed countries in 2003 and the Value added (% of GDP) in Bulgaria in 2004?
Keep it short and to the point. 19.49. What is the difference between the Value added (% of GDP) in Least developed countries in 2003 and the Value added (% of GDP) in Slovenia in 2004?
Keep it short and to the point. 26.72. What is the difference between the Value added (% of GDP) in Least developed countries in 2003 and the Value added (% of GDP) in St. Kitts and Nevis in 2004?
Your answer should be very brief. 27.25. What is the difference between the Value added (% of GDP) of Bulgaria in 2003 and the Value added (% of GDP) of Slovenia in 2004?
Ensure brevity in your answer.  7.8. What is the difference between the Value added (% of GDP) of Bulgaria in 2003 and the Value added (% of GDP) of St. Kitts and Nevis in 2004?
Provide a succinct answer. 8.33. What is the difference between the Value added (% of GDP) of Slovenia in 2003 and the Value added (% of GDP) of St. Kitts and Nevis in 2004?
Make the answer very short. 0.34. What is the average Value added (% of GDP) of Least developed countries per year?
Ensure brevity in your answer.  30.62. What is the average Value added (% of GDP) of Bulgaria per year?
Make the answer very short. 13.56. What is the average Value added (% of GDP) of Slovenia per year?
Your response must be concise. 3.22. What is the average Value added (% of GDP) of St. Kitts and Nevis per year?
Give a very brief answer. 2.28. In the year 1997, what is the difference between the Value added (% of GDP) in Least developed countries and Value added (% of GDP) in Bulgaria?
Offer a terse response. 11.08. In the year 1997, what is the difference between the Value added (% of GDP) of Least developed countries and Value added (% of GDP) of Slovenia?
Your answer should be very brief. 29.61. In the year 1997, what is the difference between the Value added (% of GDP) in Least developed countries and Value added (% of GDP) in St. Kitts and Nevis?
Your answer should be very brief. 30.02. In the year 1997, what is the difference between the Value added (% of GDP) of Bulgaria and Value added (% of GDP) of Slovenia?
Provide a succinct answer. 18.53. In the year 1997, what is the difference between the Value added (% of GDP) of Bulgaria and Value added (% of GDP) of St. Kitts and Nevis?
Provide a succinct answer. 18.94. In the year 1997, what is the difference between the Value added (% of GDP) in Slovenia and Value added (% of GDP) in St. Kitts and Nevis?
Provide a short and direct response. 0.41. In the year 1998, what is the difference between the Value added (% of GDP) in Least developed countries and Value added (% of GDP) in Bulgaria?
Ensure brevity in your answer.  17.62. In the year 1998, what is the difference between the Value added (% of GDP) of Least developed countries and Value added (% of GDP) of Slovenia?
Your answer should be very brief. 29.12. In the year 1998, what is the difference between the Value added (% of GDP) in Least developed countries and Value added (% of GDP) in St. Kitts and Nevis?
Your answer should be compact. 30.32. In the year 1998, what is the difference between the Value added (% of GDP) of Bulgaria and Value added (% of GDP) of Slovenia?
Ensure brevity in your answer.  11.5. In the year 1998, what is the difference between the Value added (% of GDP) of Bulgaria and Value added (% of GDP) of St. Kitts and Nevis?
Your answer should be very brief. 12.69. In the year 1998, what is the difference between the Value added (% of GDP) of Slovenia and Value added (% of GDP) of St. Kitts and Nevis?
Offer a very short reply. 1.19. In the year 1999, what is the difference between the Value added (% of GDP) in Least developed countries and Value added (% of GDP) in Bulgaria?
Your response must be concise. 17. In the year 1999, what is the difference between the Value added (% of GDP) in Least developed countries and Value added (% of GDP) in Slovenia?
Your answer should be very brief. 28.42. In the year 1999, what is the difference between the Value added (% of GDP) in Least developed countries and Value added (% of GDP) in St. Kitts and Nevis?
Offer a terse response. 29.64. In the year 1999, what is the difference between the Value added (% of GDP) in Bulgaria and Value added (% of GDP) in Slovenia?
Ensure brevity in your answer.  11.43. In the year 1999, what is the difference between the Value added (% of GDP) of Bulgaria and Value added (% of GDP) of St. Kitts and Nevis?
Your answer should be very brief. 12.64. In the year 1999, what is the difference between the Value added (% of GDP) in Slovenia and Value added (% of GDP) in St. Kitts and Nevis?
Keep it short and to the point. 1.21. In the year 2000, what is the difference between the Value added (% of GDP) in Least developed countries and Value added (% of GDP) in Bulgaria?
Provide a succinct answer. 17.11. In the year 2000, what is the difference between the Value added (% of GDP) in Least developed countries and Value added (% of GDP) in Slovenia?
Ensure brevity in your answer.  26.37. In the year 2000, what is the difference between the Value added (% of GDP) of Least developed countries and Value added (% of GDP) of St. Kitts and Nevis?
Keep it short and to the point. 27.95. In the year 2000, what is the difference between the Value added (% of GDP) of Bulgaria and Value added (% of GDP) of Slovenia?
Offer a very short reply. 9.27. In the year 2000, what is the difference between the Value added (% of GDP) in Bulgaria and Value added (% of GDP) in St. Kitts and Nevis?
Provide a short and direct response. 10.85. In the year 2000, what is the difference between the Value added (% of GDP) of Slovenia and Value added (% of GDP) of St. Kitts and Nevis?
Your response must be concise. 1.58. In the year 2001, what is the difference between the Value added (% of GDP) in Least developed countries and Value added (% of GDP) in Bulgaria?
Your answer should be compact. 17.44. In the year 2001, what is the difference between the Value added (% of GDP) of Least developed countries and Value added (% of GDP) of Slovenia?
Your answer should be compact. 26.52. In the year 2001, what is the difference between the Value added (% of GDP) in Least developed countries and Value added (% of GDP) in St. Kitts and Nevis?
Give a very brief answer. 27.57. In the year 2001, what is the difference between the Value added (% of GDP) in Bulgaria and Value added (% of GDP) in Slovenia?
Keep it short and to the point. 9.09. In the year 2001, what is the difference between the Value added (% of GDP) of Bulgaria and Value added (% of GDP) of St. Kitts and Nevis?
Offer a terse response. 10.13. In the year 2001, what is the difference between the Value added (% of GDP) of Slovenia and Value added (% of GDP) of St. Kitts and Nevis?
Make the answer very short. 1.05. In the year 2002, what is the difference between the Value added (% of GDP) in Least developed countries and Value added (% of GDP) in Bulgaria?
Your response must be concise. 19.26. In the year 2002, what is the difference between the Value added (% of GDP) in Least developed countries and Value added (% of GDP) in Slovenia?
Ensure brevity in your answer.  26.96. In the year 2002, what is the difference between the Value added (% of GDP) of Least developed countries and Value added (% of GDP) of St. Kitts and Nevis?
Offer a very short reply. 28.16. In the year 2002, what is the difference between the Value added (% of GDP) of Bulgaria and Value added (% of GDP) of Slovenia?
Make the answer very short. 7.71. In the year 2002, what is the difference between the Value added (% of GDP) in Bulgaria and Value added (% of GDP) in St. Kitts and Nevis?
Your answer should be very brief. 8.91. In the year 2002, what is the difference between the Value added (% of GDP) in Slovenia and Value added (% of GDP) in St. Kitts and Nevis?
Provide a succinct answer. 1.2. In the year 2003, what is the difference between the Value added (% of GDP) of Least developed countries and Value added (% of GDP) of Bulgaria?
Offer a very short reply. 18.92. In the year 2003, what is the difference between the Value added (% of GDP) of Least developed countries and Value added (% of GDP) of Slovenia?
Offer a terse response. 26.91. In the year 2003, what is the difference between the Value added (% of GDP) of Least developed countries and Value added (% of GDP) of St. Kitts and Nevis?
Offer a very short reply. 27.26. In the year 2003, what is the difference between the Value added (% of GDP) of Bulgaria and Value added (% of GDP) of Slovenia?
Provide a short and direct response. 7.99. In the year 2003, what is the difference between the Value added (% of GDP) in Bulgaria and Value added (% of GDP) in St. Kitts and Nevis?
Your answer should be very brief. 8.34. In the year 2003, what is the difference between the Value added (% of GDP) in Slovenia and Value added (% of GDP) in St. Kitts and Nevis?
Offer a terse response. 0.35. In the year 2004, what is the difference between the Value added (% of GDP) of Least developed countries and Value added (% of GDP) of Bulgaria?
Your answer should be very brief. 18.02. In the year 2004, what is the difference between the Value added (% of GDP) of Least developed countries and Value added (% of GDP) of Slovenia?
Your response must be concise. 25.26. In the year 2004, what is the difference between the Value added (% of GDP) in Least developed countries and Value added (% of GDP) in St. Kitts and Nevis?
Offer a terse response. 25.78. In the year 2004, what is the difference between the Value added (% of GDP) in Bulgaria and Value added (% of GDP) in Slovenia?
Offer a very short reply. 7.23. In the year 2004, what is the difference between the Value added (% of GDP) of Bulgaria and Value added (% of GDP) of St. Kitts and Nevis?
Make the answer very short. 7.76. In the year 2004, what is the difference between the Value added (% of GDP) of Slovenia and Value added (% of GDP) of St. Kitts and Nevis?
Your response must be concise. 0.53. What is the ratio of the Value added (% of GDP) of Least developed countries in 1997 to that in 1998?
Give a very brief answer. 1.02. What is the ratio of the Value added (% of GDP) of Bulgaria in 1997 to that in 1998?
Offer a very short reply. 1.47. What is the ratio of the Value added (% of GDP) of Slovenia in 1997 to that in 1998?
Make the answer very short. 1.04. What is the ratio of the Value added (% of GDP) in St. Kitts and Nevis in 1997 to that in 1998?
Your answer should be compact. 1.34. What is the ratio of the Value added (% of GDP) of Least developed countries in 1997 to that in 1999?
Your response must be concise. 1.06. What is the ratio of the Value added (% of GDP) in Bulgaria in 1997 to that in 1999?
Ensure brevity in your answer.  1.53. What is the ratio of the Value added (% of GDP) of Slovenia in 1997 to that in 1999?
Offer a very short reply. 1.23. What is the ratio of the Value added (% of GDP) in St. Kitts and Nevis in 1997 to that in 1999?
Provide a succinct answer. 1.75. What is the ratio of the Value added (% of GDP) of Least developed countries in 1997 to that in 2000?
Give a very brief answer. 1.13. What is the ratio of the Value added (% of GDP) of Bulgaria in 1997 to that in 2000?
Provide a succinct answer. 1.8. What is the ratio of the Value added (% of GDP) of Slovenia in 1997 to that in 2000?
Make the answer very short. 1.23. What is the ratio of the Value added (% of GDP) of St. Kitts and Nevis in 1997 to that in 2000?
Your response must be concise. 2.11. What is the ratio of the Value added (% of GDP) in Least developed countries in 1997 to that in 2001?
Make the answer very short. 1.14. What is the ratio of the Value added (% of GDP) in Bulgaria in 1997 to that in 2001?
Keep it short and to the point. 1.87. What is the ratio of the Value added (% of GDP) of Slovenia in 1997 to that in 2001?
Provide a succinct answer. 1.37. What is the ratio of the Value added (% of GDP) of St. Kitts and Nevis in 1997 to that in 2001?
Ensure brevity in your answer.  1.9. What is the ratio of the Value added (% of GDP) of Least developed countries in 1997 to that in 2002?
Your answer should be compact. 1.12. What is the ratio of the Value added (% of GDP) in Bulgaria in 1997 to that in 2002?
Ensure brevity in your answer.  2.07. What is the ratio of the Value added (% of GDP) of Slovenia in 1997 to that in 2002?
Provide a succinct answer. 1.27. What is the ratio of the Value added (% of GDP) in St. Kitts and Nevis in 1997 to that in 2002?
Make the answer very short. 1.82. What is the ratio of the Value added (% of GDP) in Least developed countries in 1997 to that in 2003?
Provide a succinct answer. 1.15. What is the ratio of the Value added (% of GDP) in Bulgaria in 1997 to that in 2003?
Provide a short and direct response. 2.17. What is the ratio of the Value added (% of GDP) of Slovenia in 1997 to that in 2003?
Keep it short and to the point. 1.68. What is the ratio of the Value added (% of GDP) in St. Kitts and Nevis in 1997 to that in 2003?
Your answer should be compact. 1.77. What is the ratio of the Value added (% of GDP) of Least developed countries in 1997 to that in 2004?
Provide a short and direct response. 1.21. What is the ratio of the Value added (% of GDP) in Bulgaria in 1997 to that in 2004?
Make the answer very short. 2.3. What is the ratio of the Value added (% of GDP) of Slovenia in 1997 to that in 2004?
Provide a short and direct response. 1.56. What is the ratio of the Value added (% of GDP) of St. Kitts and Nevis in 1997 to that in 2004?
Ensure brevity in your answer.  1.76. What is the ratio of the Value added (% of GDP) in Least developed countries in 1998 to that in 1999?
Give a very brief answer. 1.04. What is the ratio of the Value added (% of GDP) in Bulgaria in 1998 to that in 1999?
Give a very brief answer. 1.05. What is the ratio of the Value added (% of GDP) of Slovenia in 1998 to that in 1999?
Keep it short and to the point. 1.19. What is the ratio of the Value added (% of GDP) in St. Kitts and Nevis in 1998 to that in 1999?
Give a very brief answer. 1.31. What is the ratio of the Value added (% of GDP) in Least developed countries in 1998 to that in 2000?
Your answer should be compact. 1.11. What is the ratio of the Value added (% of GDP) of Bulgaria in 1998 to that in 2000?
Give a very brief answer. 1.23. What is the ratio of the Value added (% of GDP) of Slovenia in 1998 to that in 2000?
Your response must be concise. 1.18. What is the ratio of the Value added (% of GDP) in St. Kitts and Nevis in 1998 to that in 2000?
Keep it short and to the point. 1.57. What is the ratio of the Value added (% of GDP) of Least developed countries in 1998 to that in 2001?
Your answer should be compact. 1.12. What is the ratio of the Value added (% of GDP) in Bulgaria in 1998 to that in 2001?
Give a very brief answer. 1.28. What is the ratio of the Value added (% of GDP) of Slovenia in 1998 to that in 2001?
Your response must be concise. 1.32. What is the ratio of the Value added (% of GDP) in St. Kitts and Nevis in 1998 to that in 2001?
Ensure brevity in your answer.  1.41. What is the ratio of the Value added (% of GDP) in Least developed countries in 1998 to that in 2002?
Offer a terse response. 1.1. What is the ratio of the Value added (% of GDP) of Bulgaria in 1998 to that in 2002?
Your response must be concise. 1.41. What is the ratio of the Value added (% of GDP) in Slovenia in 1998 to that in 2002?
Your answer should be very brief. 1.22. What is the ratio of the Value added (% of GDP) of St. Kitts and Nevis in 1998 to that in 2002?
Make the answer very short. 1.36. What is the ratio of the Value added (% of GDP) in Least developed countries in 1998 to that in 2003?
Give a very brief answer. 1.13. What is the ratio of the Value added (% of GDP) of Bulgaria in 1998 to that in 2003?
Ensure brevity in your answer.  1.48. What is the ratio of the Value added (% of GDP) in Slovenia in 1998 to that in 2003?
Provide a short and direct response. 1.62. What is the ratio of the Value added (% of GDP) in St. Kitts and Nevis in 1998 to that in 2003?
Offer a terse response. 1.32. What is the ratio of the Value added (% of GDP) of Least developed countries in 1998 to that in 2004?
Provide a succinct answer. 1.19. What is the ratio of the Value added (% of GDP) of Bulgaria in 1998 to that in 2004?
Your answer should be very brief. 1.57. What is the ratio of the Value added (% of GDP) in Slovenia in 1998 to that in 2004?
Give a very brief answer. 1.5. What is the ratio of the Value added (% of GDP) of St. Kitts and Nevis in 1998 to that in 2004?
Make the answer very short. 1.31. What is the ratio of the Value added (% of GDP) in Least developed countries in 1999 to that in 2000?
Provide a short and direct response. 1.07. What is the ratio of the Value added (% of GDP) in Bulgaria in 1999 to that in 2000?
Provide a short and direct response. 1.17. What is the ratio of the Value added (% of GDP) of Slovenia in 1999 to that in 2000?
Keep it short and to the point. 0.99. What is the ratio of the Value added (% of GDP) of St. Kitts and Nevis in 1999 to that in 2000?
Make the answer very short. 1.2. What is the ratio of the Value added (% of GDP) of Least developed countries in 1999 to that in 2001?
Give a very brief answer. 1.08. What is the ratio of the Value added (% of GDP) in Bulgaria in 1999 to that in 2001?
Your answer should be compact. 1.22. What is the ratio of the Value added (% of GDP) in Slovenia in 1999 to that in 2001?
Your response must be concise. 1.11. What is the ratio of the Value added (% of GDP) in St. Kitts and Nevis in 1999 to that in 2001?
Offer a terse response. 1.08. What is the ratio of the Value added (% of GDP) of Least developed countries in 1999 to that in 2002?
Your answer should be very brief. 1.05. What is the ratio of the Value added (% of GDP) of Bulgaria in 1999 to that in 2002?
Keep it short and to the point. 1.35. What is the ratio of the Value added (% of GDP) in Slovenia in 1999 to that in 2002?
Keep it short and to the point. 1.03. What is the ratio of the Value added (% of GDP) of St. Kitts and Nevis in 1999 to that in 2002?
Offer a terse response. 1.04. What is the ratio of the Value added (% of GDP) in Least developed countries in 1999 to that in 2003?
Offer a terse response. 1.08. What is the ratio of the Value added (% of GDP) of Bulgaria in 1999 to that in 2003?
Keep it short and to the point. 1.41. What is the ratio of the Value added (% of GDP) in Slovenia in 1999 to that in 2003?
Your response must be concise. 1.37. What is the ratio of the Value added (% of GDP) in St. Kitts and Nevis in 1999 to that in 2003?
Give a very brief answer. 1.01. What is the ratio of the Value added (% of GDP) in Least developed countries in 1999 to that in 2004?
Ensure brevity in your answer.  1.14. What is the ratio of the Value added (% of GDP) in Bulgaria in 1999 to that in 2004?
Give a very brief answer. 1.5. What is the ratio of the Value added (% of GDP) in Slovenia in 1999 to that in 2004?
Provide a succinct answer. 1.27. What is the ratio of the Value added (% of GDP) in Least developed countries in 2000 to that in 2001?
Offer a very short reply. 1.01. What is the ratio of the Value added (% of GDP) of Bulgaria in 2000 to that in 2001?
Ensure brevity in your answer.  1.04. What is the ratio of the Value added (% of GDP) in Slovenia in 2000 to that in 2001?
Ensure brevity in your answer.  1.11. What is the ratio of the Value added (% of GDP) in St. Kitts and Nevis in 2000 to that in 2001?
Ensure brevity in your answer.  0.9. What is the ratio of the Value added (% of GDP) of Least developed countries in 2000 to that in 2002?
Ensure brevity in your answer.  0.98. What is the ratio of the Value added (% of GDP) of Bulgaria in 2000 to that in 2002?
Offer a terse response. 1.15. What is the ratio of the Value added (% of GDP) of Slovenia in 2000 to that in 2002?
Your answer should be compact. 1.03. What is the ratio of the Value added (% of GDP) in St. Kitts and Nevis in 2000 to that in 2002?
Offer a terse response. 0.86. What is the ratio of the Value added (% of GDP) in Least developed countries in 2000 to that in 2003?
Offer a very short reply. 1.01. What is the ratio of the Value added (% of GDP) in Bulgaria in 2000 to that in 2003?
Offer a very short reply. 1.21. What is the ratio of the Value added (% of GDP) in Slovenia in 2000 to that in 2003?
Make the answer very short. 1.37. What is the ratio of the Value added (% of GDP) in St. Kitts and Nevis in 2000 to that in 2003?
Ensure brevity in your answer.  0.84. What is the ratio of the Value added (% of GDP) of Least developed countries in 2000 to that in 2004?
Offer a very short reply. 1.07. What is the ratio of the Value added (% of GDP) in Bulgaria in 2000 to that in 2004?
Ensure brevity in your answer.  1.28. What is the ratio of the Value added (% of GDP) in Slovenia in 2000 to that in 2004?
Provide a short and direct response. 1.27. What is the ratio of the Value added (% of GDP) in St. Kitts and Nevis in 2000 to that in 2004?
Keep it short and to the point. 0.84. What is the ratio of the Value added (% of GDP) in Least developed countries in 2001 to that in 2002?
Offer a terse response. 0.98. What is the ratio of the Value added (% of GDP) in Bulgaria in 2001 to that in 2002?
Provide a succinct answer. 1.11. What is the ratio of the Value added (% of GDP) in Slovenia in 2001 to that in 2002?
Make the answer very short. 0.93. What is the ratio of the Value added (% of GDP) of St. Kitts and Nevis in 2001 to that in 2002?
Your answer should be very brief. 0.96. What is the ratio of the Value added (% of GDP) in Least developed countries in 2001 to that in 2003?
Your response must be concise. 1.01. What is the ratio of the Value added (% of GDP) in Bulgaria in 2001 to that in 2003?
Ensure brevity in your answer.  1.16. What is the ratio of the Value added (% of GDP) in Slovenia in 2001 to that in 2003?
Provide a succinct answer. 1.23. What is the ratio of the Value added (% of GDP) of St. Kitts and Nevis in 2001 to that in 2003?
Provide a succinct answer. 0.93. What is the ratio of the Value added (% of GDP) of Least developed countries in 2001 to that in 2004?
Your response must be concise. 1.06. What is the ratio of the Value added (% of GDP) in Bulgaria in 2001 to that in 2004?
Make the answer very short. 1.23. What is the ratio of the Value added (% of GDP) of Slovenia in 2001 to that in 2004?
Offer a terse response. 1.14. What is the ratio of the Value added (% of GDP) in St. Kitts and Nevis in 2001 to that in 2004?
Your answer should be very brief. 0.93. What is the ratio of the Value added (% of GDP) in Least developed countries in 2002 to that in 2003?
Your answer should be compact. 1.03. What is the ratio of the Value added (% of GDP) in Bulgaria in 2002 to that in 2003?
Keep it short and to the point. 1.05. What is the ratio of the Value added (% of GDP) in Slovenia in 2002 to that in 2003?
Your answer should be very brief. 1.33. What is the ratio of the Value added (% of GDP) of St. Kitts and Nevis in 2002 to that in 2003?
Keep it short and to the point. 0.97. What is the ratio of the Value added (% of GDP) in Least developed countries in 2002 to that in 2004?
Offer a very short reply. 1.08. What is the ratio of the Value added (% of GDP) of Bulgaria in 2002 to that in 2004?
Offer a very short reply. 1.11. What is the ratio of the Value added (% of GDP) of Slovenia in 2002 to that in 2004?
Your answer should be very brief. 1.23. What is the ratio of the Value added (% of GDP) of St. Kitts and Nevis in 2002 to that in 2004?
Offer a terse response. 0.97. What is the ratio of the Value added (% of GDP) in Least developed countries in 2003 to that in 2004?
Keep it short and to the point. 1.05. What is the ratio of the Value added (% of GDP) of Bulgaria in 2003 to that in 2004?
Your answer should be compact. 1.06. What is the ratio of the Value added (% of GDP) of Slovenia in 2003 to that in 2004?
Your answer should be compact. 0.93. What is the difference between the highest and the second highest Value added (% of GDP) in Least developed countries?
Your response must be concise. 0.63. What is the difference between the highest and the second highest Value added (% of GDP) in Bulgaria?
Your answer should be compact. 7.18. What is the difference between the highest and the second highest Value added (% of GDP) in Slovenia?
Give a very brief answer. 0.15. What is the difference between the highest and the second highest Value added (% of GDP) in St. Kitts and Nevis?
Give a very brief answer. 0.93. What is the difference between the highest and the lowest Value added (% of GDP) of Least developed countries?
Ensure brevity in your answer.  5.81. What is the difference between the highest and the lowest Value added (% of GDP) of Bulgaria?
Your answer should be compact. 12.75. What is the difference between the highest and the lowest Value added (% of GDP) in Slovenia?
Give a very brief answer. 1.65. What is the difference between the highest and the lowest Value added (% of GDP) of St. Kitts and Nevis?
Provide a short and direct response. 1.92. 